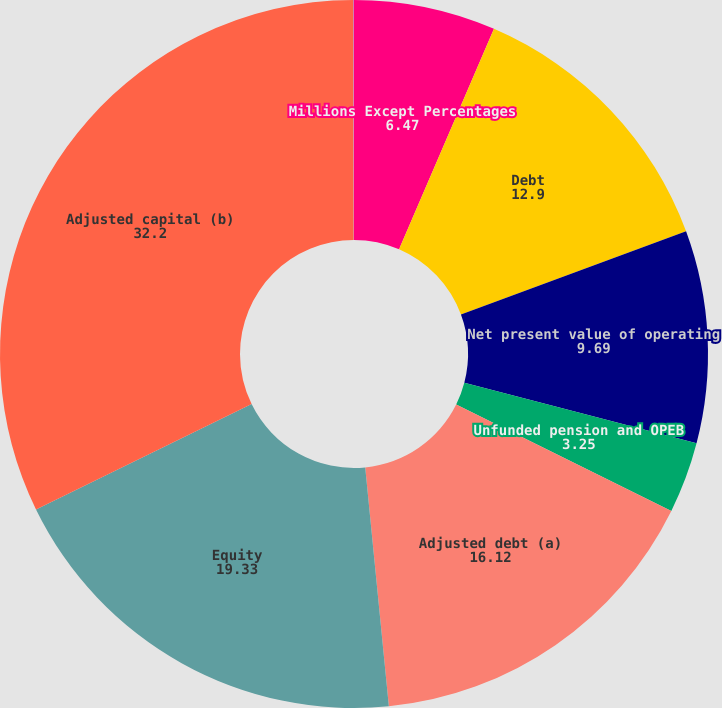<chart> <loc_0><loc_0><loc_500><loc_500><pie_chart><fcel>Millions Except Percentages<fcel>Debt<fcel>Net present value of operating<fcel>Unfunded pension and OPEB<fcel>Adjusted debt (a)<fcel>Equity<fcel>Adjusted capital (b)<fcel>Adjusted debt to capital (a/b)<nl><fcel>6.47%<fcel>12.9%<fcel>9.69%<fcel>3.25%<fcel>16.12%<fcel>19.33%<fcel>32.2%<fcel>0.04%<nl></chart> 